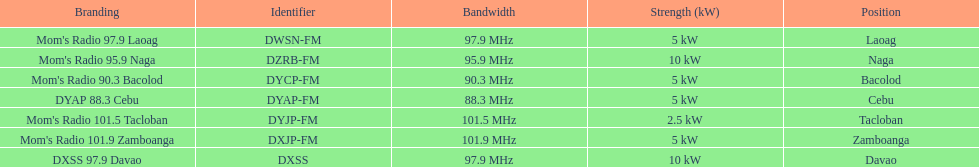What is the total number of stations with frequencies above 100 mhz? 2. 